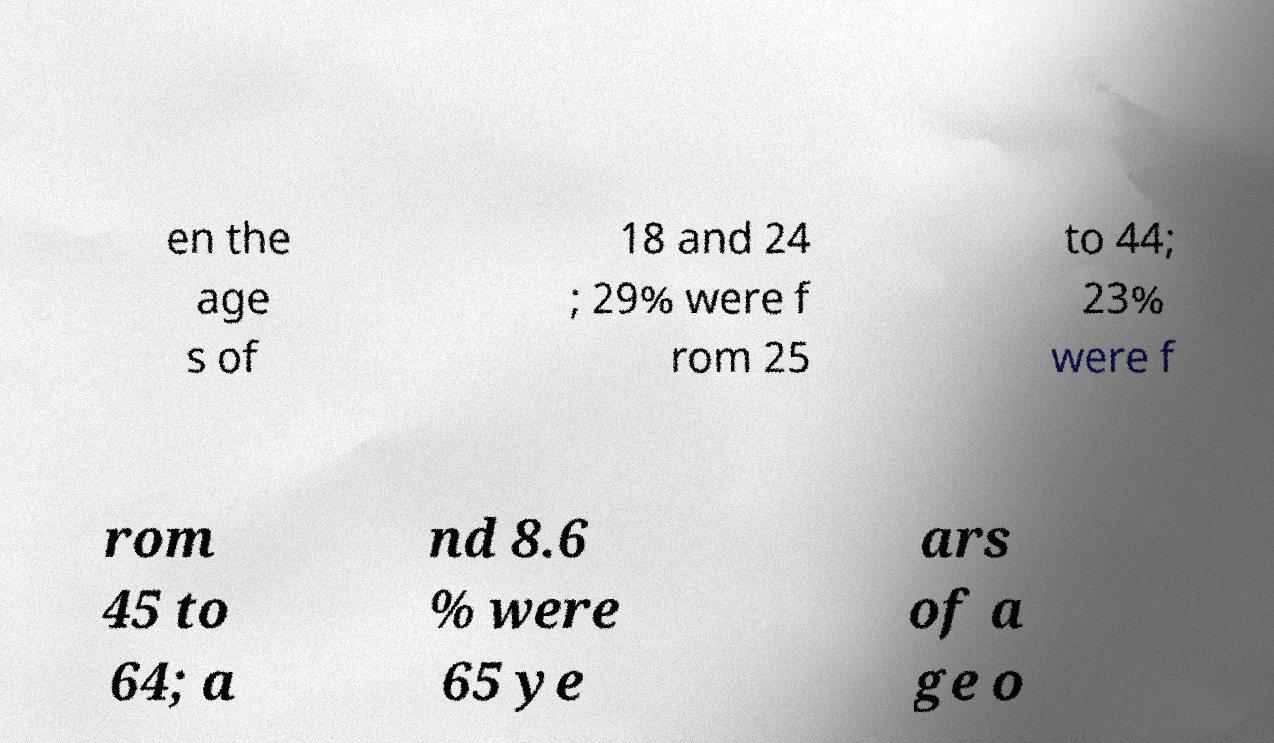Please read and relay the text visible in this image. What does it say? en the age s of 18 and 24 ; 29% were f rom 25 to 44; 23% were f rom 45 to 64; a nd 8.6 % were 65 ye ars of a ge o 